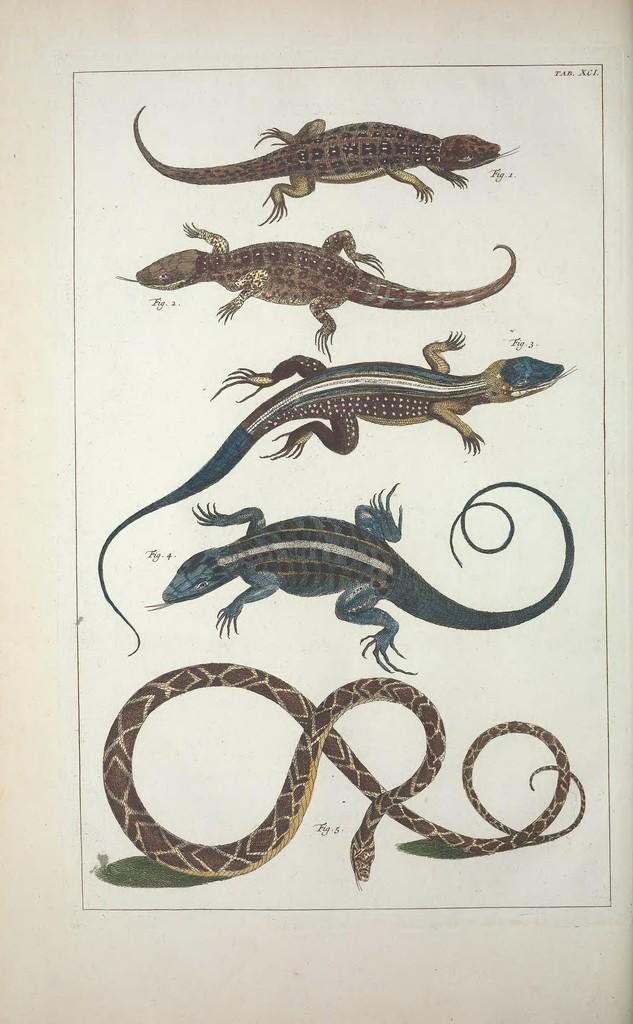What type of animals are depicted in the images in the picture? The images in the picture depict reptiles. What material are the images printed on? The images are printed on paper. How many branches can be seen in the image? There are no branches visible in the image; it only contains pictures of reptiles printed on paper. What type of flock is present in the image? There is no flock present in the image; it only contains pictures of reptiles printed on paper. 